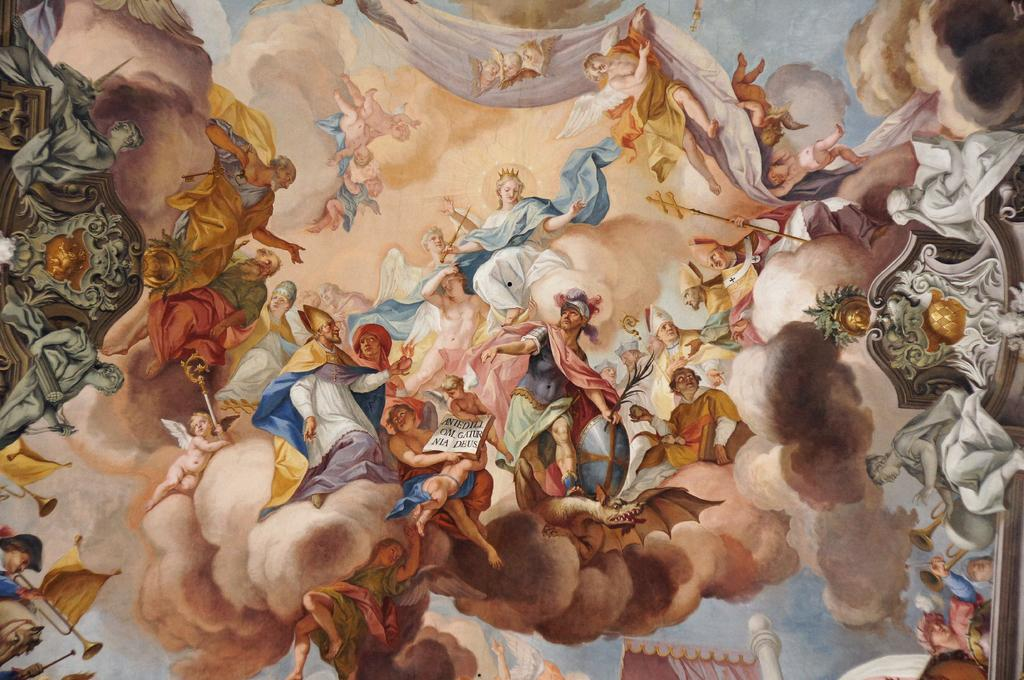What is depicted in the painting? There is a group of people in the painting. What else can be seen in the painting? There is smoke, a chariot, musical instruments, swords, cloth, and the sky visible in the painting. How many chairs are present in the painting? There are no chairs visible in the painting. What type of wood is used to create the chariot in the painting? The painting does not provide information about the type of wood used to create the chariot. 